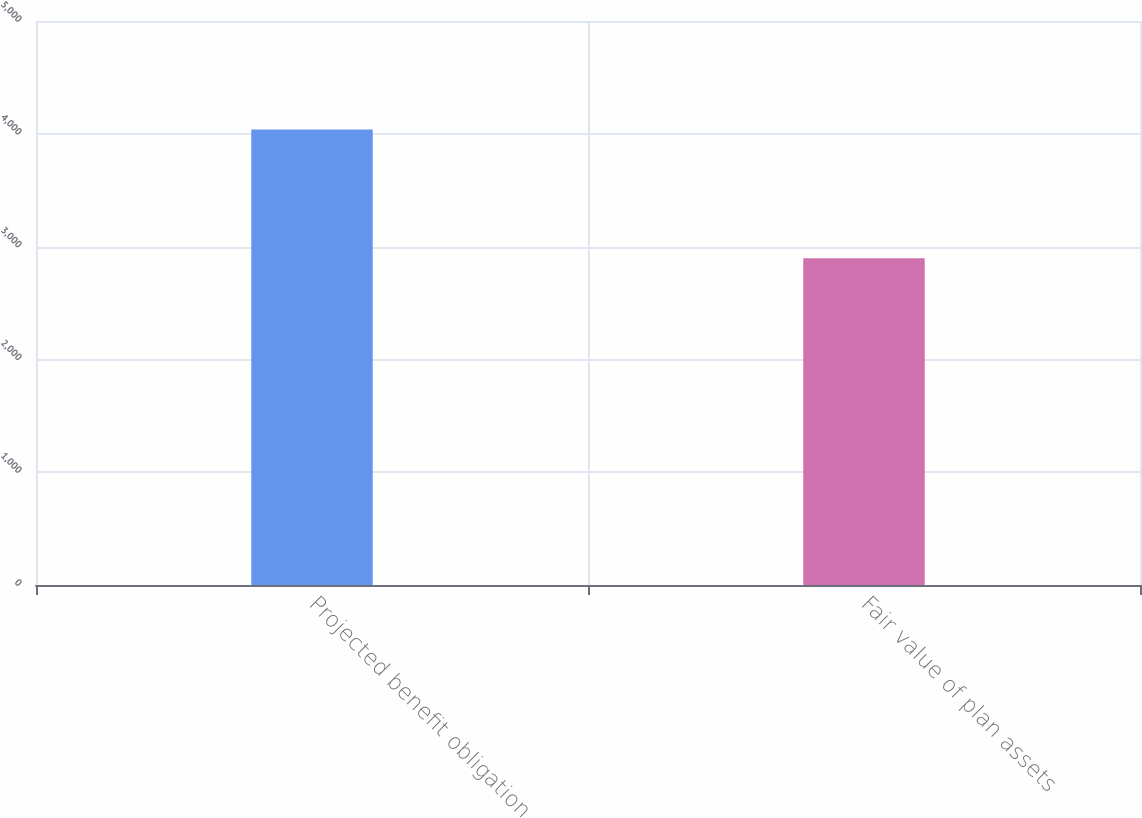Convert chart to OTSL. <chart><loc_0><loc_0><loc_500><loc_500><bar_chart><fcel>Projected benefit obligation<fcel>Fair value of plan assets<nl><fcel>4038<fcel>2897<nl></chart> 